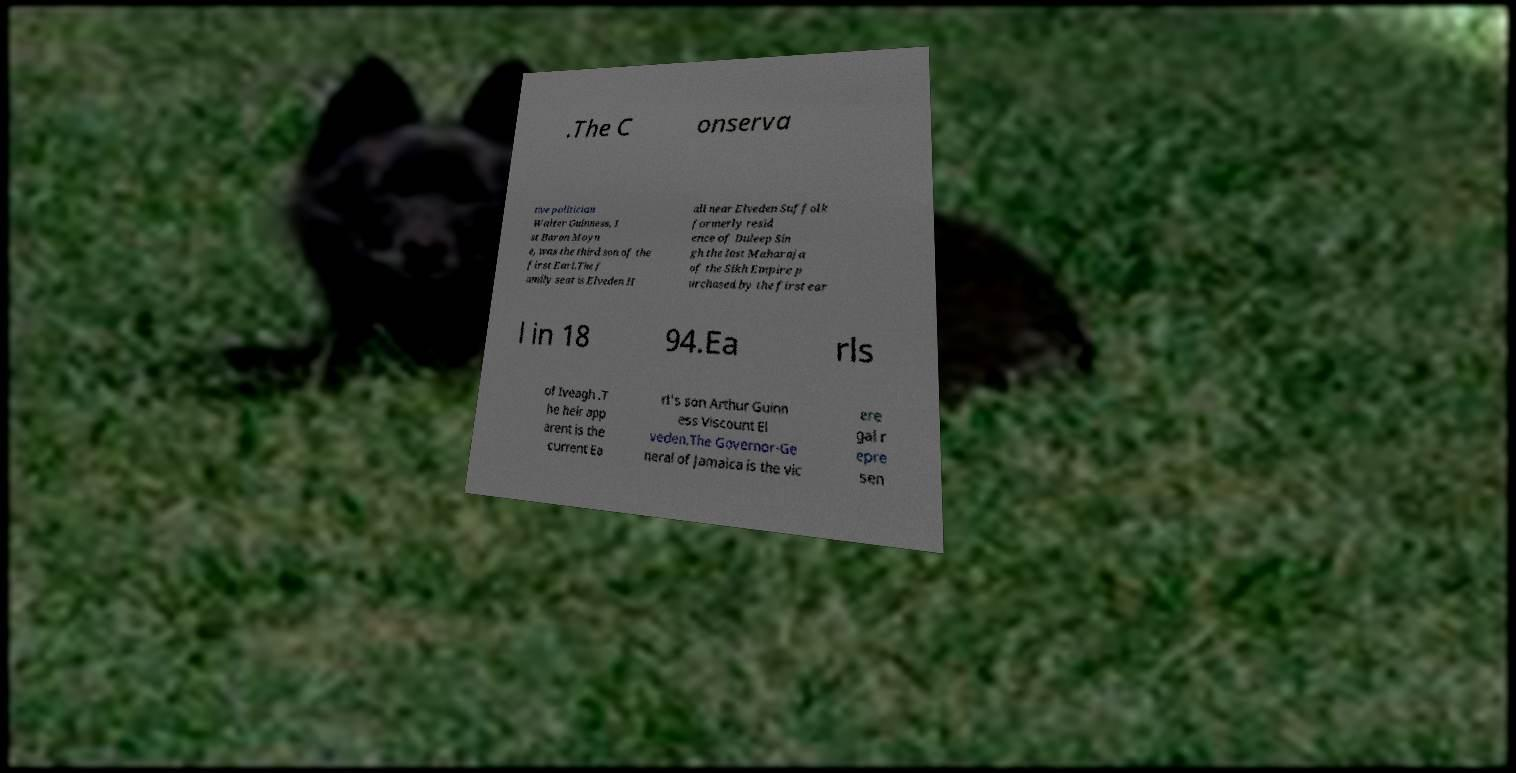Could you extract and type out the text from this image? .The C onserva tive politician Walter Guinness, 1 st Baron Moyn e, was the third son of the first Earl.The f amily seat is Elveden H all near Elveden Suffolk formerly resid ence of Duleep Sin gh the last Maharaja of the Sikh Empire p urchased by the first ear l in 18 94.Ea rls of Iveagh .T he heir app arent is the current Ea rl's son Arthur Guinn ess Viscount El veden.The Governor-Ge neral of Jamaica is the vic ere gal r epre sen 